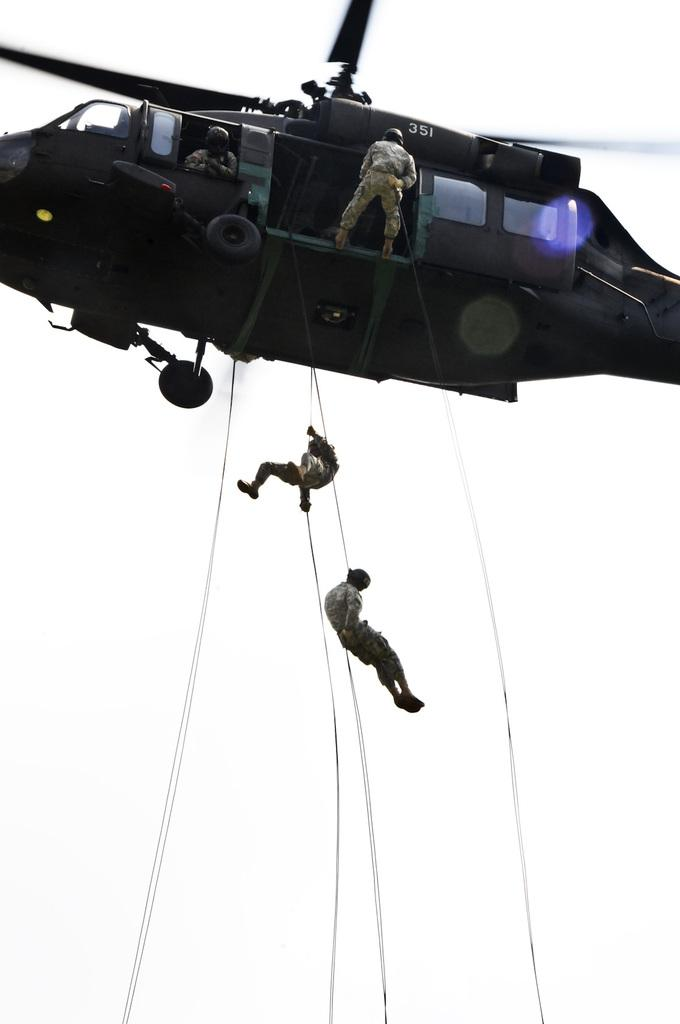What are the people in the image wearing? The persons in the image are wearing clothes. What can be seen at the top of the image? There is a helicopter at the top of the image. What are the two persons in the middle of the image doing? Two persons are hanging on ropes in the middle of the image. What type of mountain can be seen in the background of the image? There is no mountain visible in the image. 